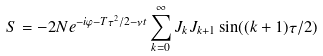<formula> <loc_0><loc_0><loc_500><loc_500>S = - 2 N e ^ { - i \varphi - T \tau ^ { 2 } / 2 - \nu t } \sum _ { k = 0 } ^ { \infty } J _ { k } J _ { k + 1 } \sin ( ( k + 1 ) \tau / 2 )</formula> 